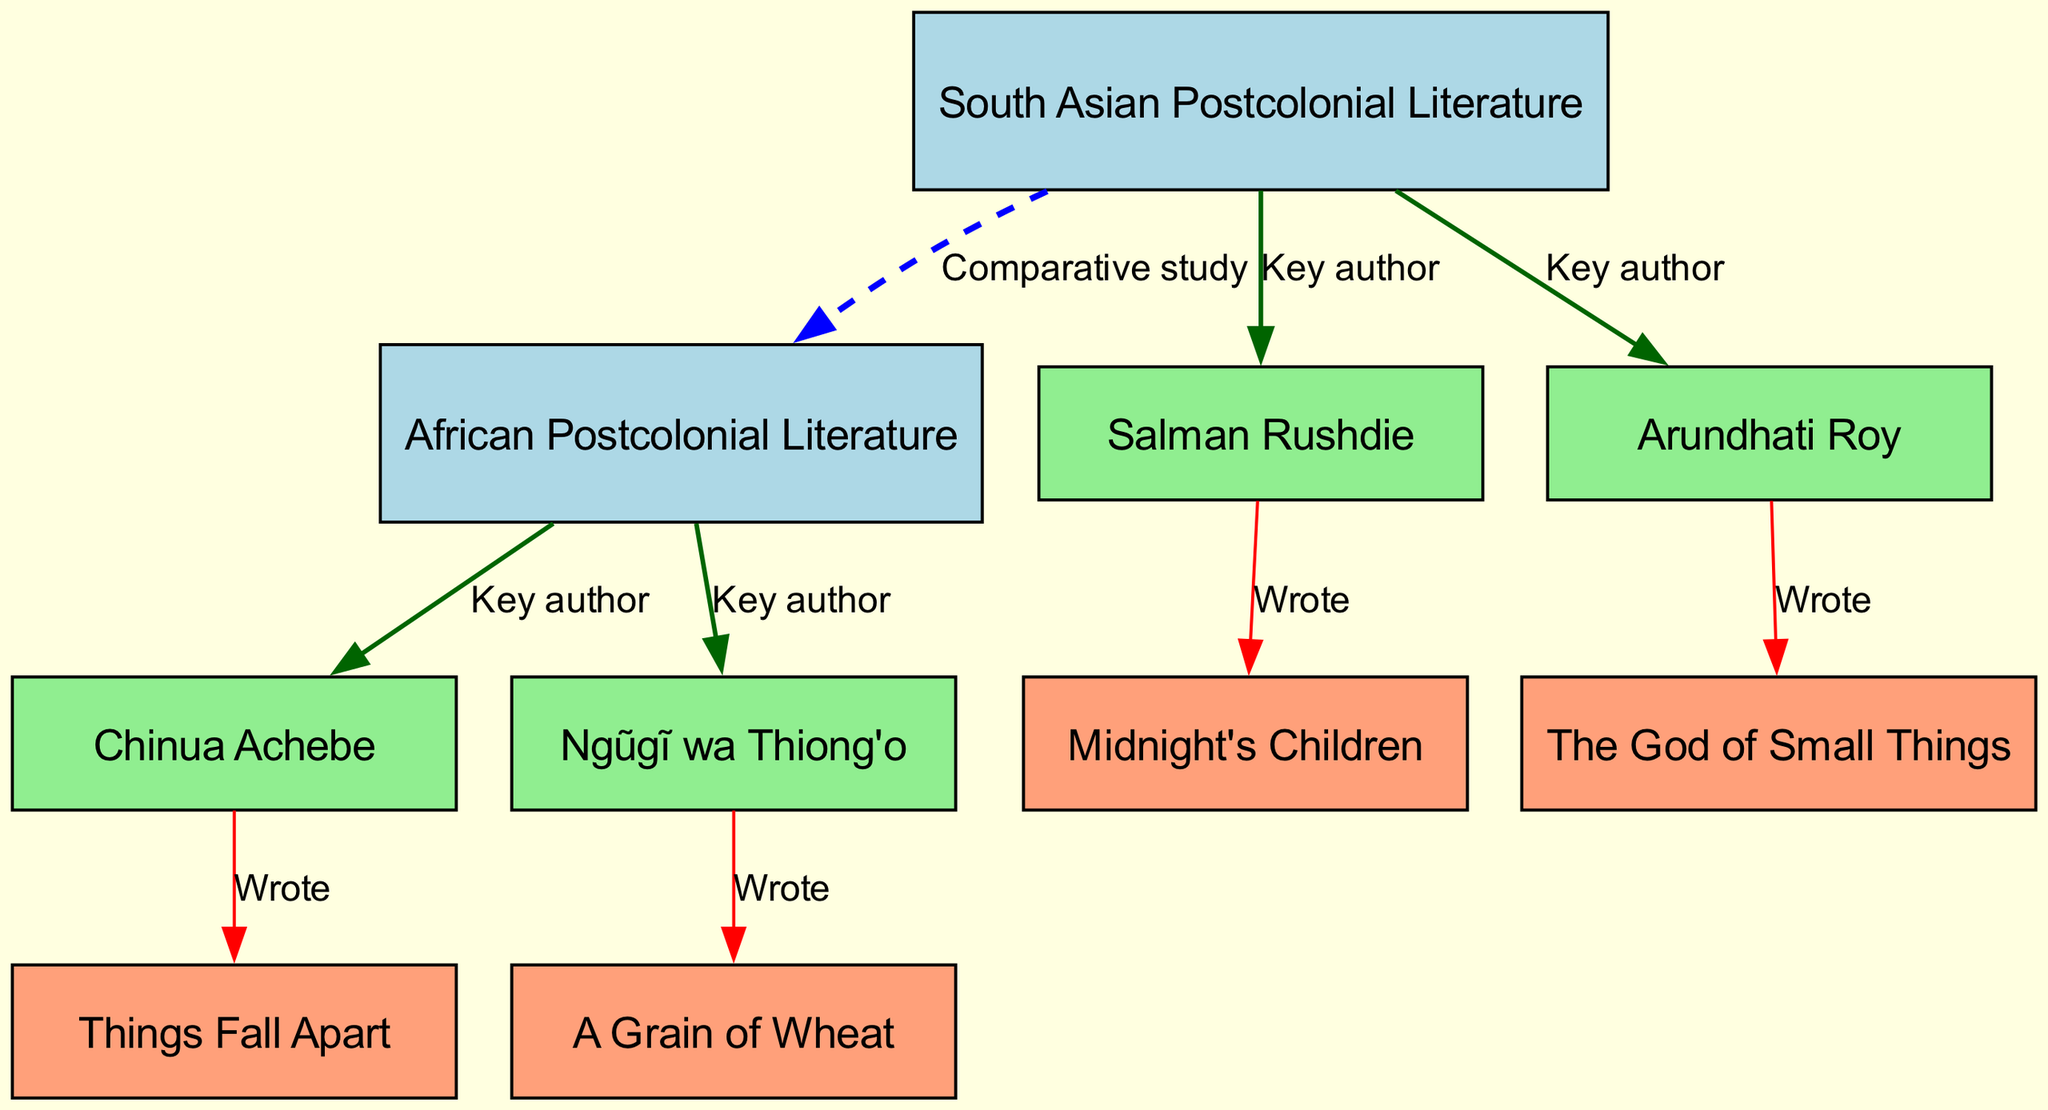What is the total number of nodes in the diagram? The diagram contains nodes for South Asian postcolonial literature, African postcolonial literature, four key authors from both regions, and four key works. Counting these, we find a total of 10 nodes.
Answer: 10 Which author wrote "Things Fall Apart"? The edge in the diagram indicates that Chinua Achebe is connected to "Things Fall Apart". Therefore, he is the author of this work.
Answer: Chinua Achebe How many key authors are represented in South Asian literature? The nodes connected to South Asian postcolonial literature are Salman Rushdie and Arundhati Roy, giving a total of 2 key authors in this category.
Answer: 2 Which work is connected to Ngũgĩ wa Thiong'o? The diagram shows that Ngũgĩ wa Thiong'o is linked to the work "A Grain of Wheat". Hence, this is the work associated with him.
Answer: A Grain of Wheat What relationship exists between South Asian and African postcolonial literature? The diagram indicates a dashed edge labeled "Comparative study" connecting South Asian and African postcolonial literature. This implies they can be studied comparatively.
Answer: Comparative study Which author is associated with the work "Midnight's Children"? The connection in the diagram shows that Salman Rushdie wrote "Midnight's Children". Hence, he is the author associated with this work.
Answer: Salman Rushdie How many authors in total are represented in the diagram? The nodes connected to both South Asian and African postcolonial literature represent four authors from each side. Therefore, 4 + 4 gives a total of 8 authors.
Answer: 8 What type of literature is "The God of Small Things" associated with? The diagram links "The God of Small Things" to Arundhati Roy, who is identified as a key author in South Asian postcolonial literature. Therefore, this work is associated with South Asian literature.
Answer: South Asian Postcolonial Literature 